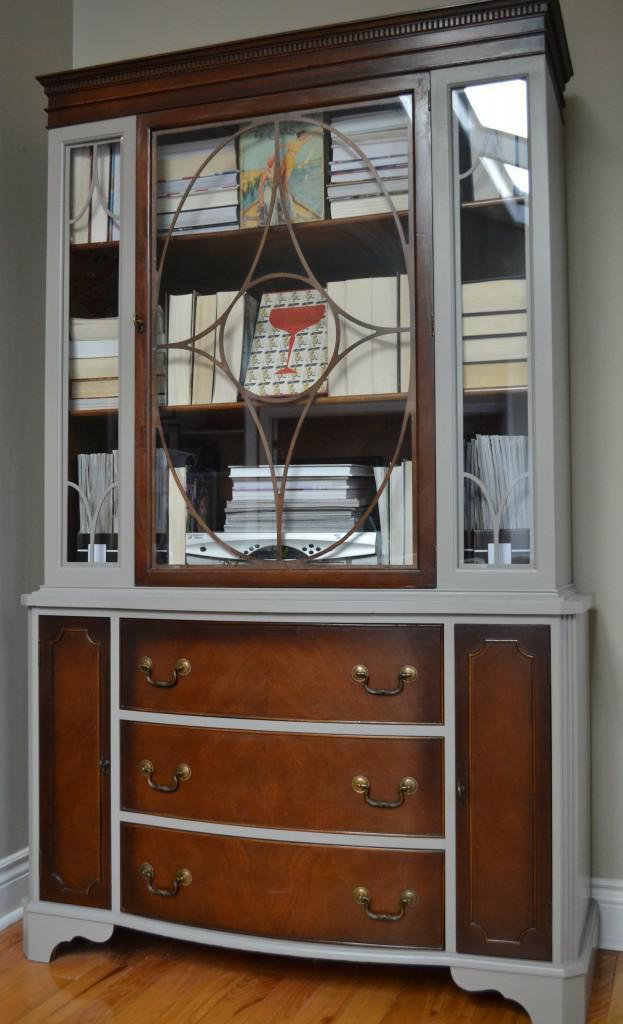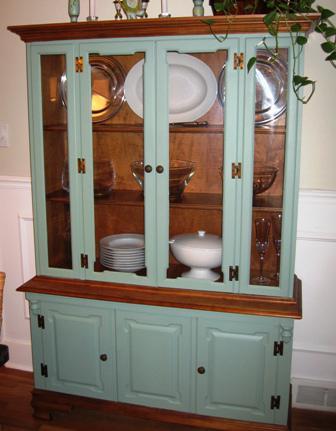The first image is the image on the left, the second image is the image on the right. Considering the images on both sides, is "There are objects in the white cabinet in the image on the left." valid? Answer yes or no. No. The first image is the image on the left, the second image is the image on the right. Analyze the images presented: Is the assertion "The right image contains a chair." valid? Answer yes or no. No. 